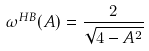Convert formula to latex. <formula><loc_0><loc_0><loc_500><loc_500>\omega ^ { H B } ( A ) = \frac { 2 } { \sqrt { 4 - A ^ { 2 } } }</formula> 